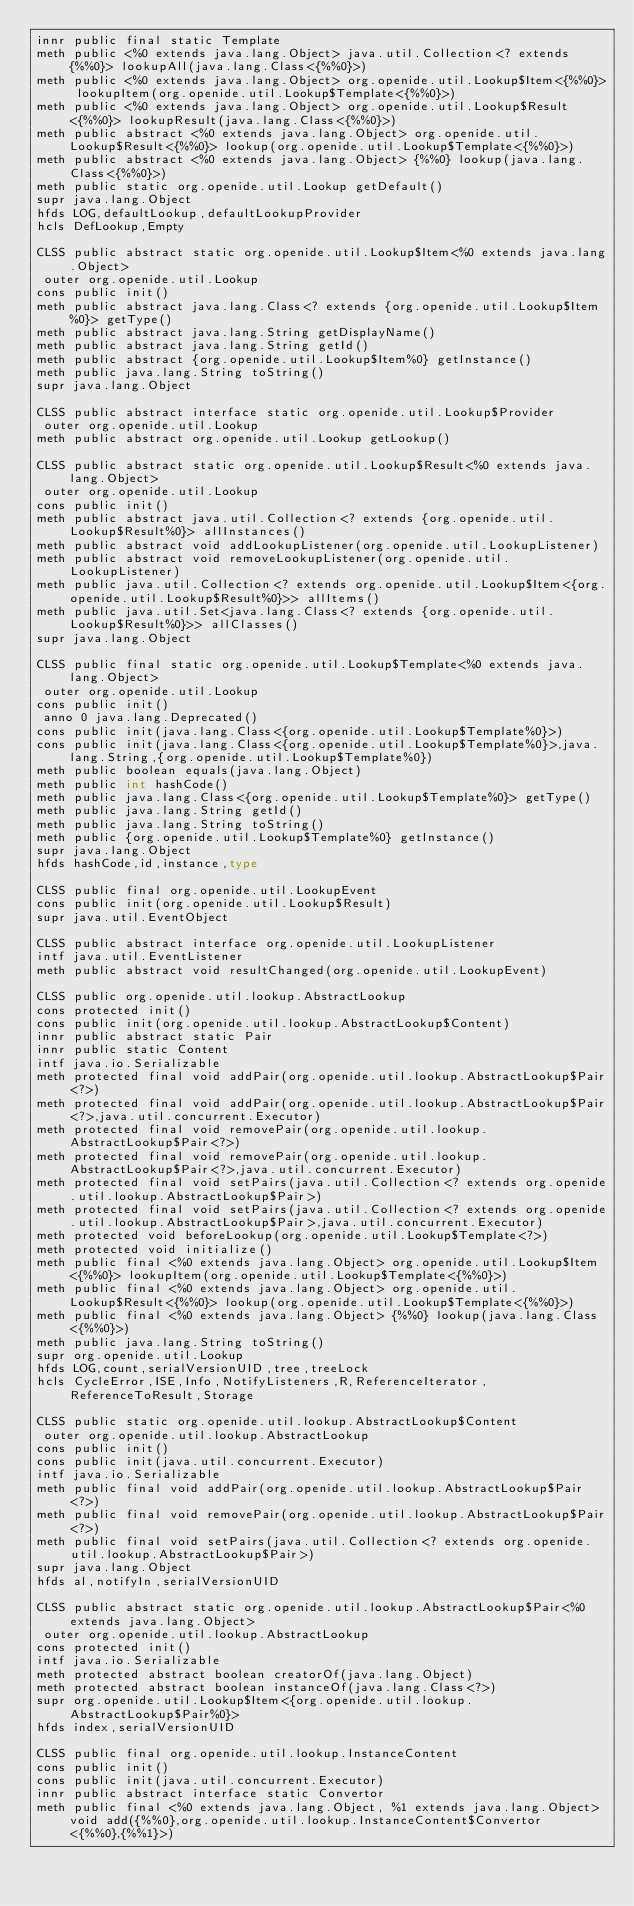<code> <loc_0><loc_0><loc_500><loc_500><_SML_>innr public final static Template
meth public <%0 extends java.lang.Object> java.util.Collection<? extends {%%0}> lookupAll(java.lang.Class<{%%0}>)
meth public <%0 extends java.lang.Object> org.openide.util.Lookup$Item<{%%0}> lookupItem(org.openide.util.Lookup$Template<{%%0}>)
meth public <%0 extends java.lang.Object> org.openide.util.Lookup$Result<{%%0}> lookupResult(java.lang.Class<{%%0}>)
meth public abstract <%0 extends java.lang.Object> org.openide.util.Lookup$Result<{%%0}> lookup(org.openide.util.Lookup$Template<{%%0}>)
meth public abstract <%0 extends java.lang.Object> {%%0} lookup(java.lang.Class<{%%0}>)
meth public static org.openide.util.Lookup getDefault()
supr java.lang.Object
hfds LOG,defaultLookup,defaultLookupProvider
hcls DefLookup,Empty

CLSS public abstract static org.openide.util.Lookup$Item<%0 extends java.lang.Object>
 outer org.openide.util.Lookup
cons public init()
meth public abstract java.lang.Class<? extends {org.openide.util.Lookup$Item%0}> getType()
meth public abstract java.lang.String getDisplayName()
meth public abstract java.lang.String getId()
meth public abstract {org.openide.util.Lookup$Item%0} getInstance()
meth public java.lang.String toString()
supr java.lang.Object

CLSS public abstract interface static org.openide.util.Lookup$Provider
 outer org.openide.util.Lookup
meth public abstract org.openide.util.Lookup getLookup()

CLSS public abstract static org.openide.util.Lookup$Result<%0 extends java.lang.Object>
 outer org.openide.util.Lookup
cons public init()
meth public abstract java.util.Collection<? extends {org.openide.util.Lookup$Result%0}> allInstances()
meth public abstract void addLookupListener(org.openide.util.LookupListener)
meth public abstract void removeLookupListener(org.openide.util.LookupListener)
meth public java.util.Collection<? extends org.openide.util.Lookup$Item<{org.openide.util.Lookup$Result%0}>> allItems()
meth public java.util.Set<java.lang.Class<? extends {org.openide.util.Lookup$Result%0}>> allClasses()
supr java.lang.Object

CLSS public final static org.openide.util.Lookup$Template<%0 extends java.lang.Object>
 outer org.openide.util.Lookup
cons public init()
 anno 0 java.lang.Deprecated()
cons public init(java.lang.Class<{org.openide.util.Lookup$Template%0}>)
cons public init(java.lang.Class<{org.openide.util.Lookup$Template%0}>,java.lang.String,{org.openide.util.Lookup$Template%0})
meth public boolean equals(java.lang.Object)
meth public int hashCode()
meth public java.lang.Class<{org.openide.util.Lookup$Template%0}> getType()
meth public java.lang.String getId()
meth public java.lang.String toString()
meth public {org.openide.util.Lookup$Template%0} getInstance()
supr java.lang.Object
hfds hashCode,id,instance,type

CLSS public final org.openide.util.LookupEvent
cons public init(org.openide.util.Lookup$Result)
supr java.util.EventObject

CLSS public abstract interface org.openide.util.LookupListener
intf java.util.EventListener
meth public abstract void resultChanged(org.openide.util.LookupEvent)

CLSS public org.openide.util.lookup.AbstractLookup
cons protected init()
cons public init(org.openide.util.lookup.AbstractLookup$Content)
innr public abstract static Pair
innr public static Content
intf java.io.Serializable
meth protected final void addPair(org.openide.util.lookup.AbstractLookup$Pair<?>)
meth protected final void addPair(org.openide.util.lookup.AbstractLookup$Pair<?>,java.util.concurrent.Executor)
meth protected final void removePair(org.openide.util.lookup.AbstractLookup$Pair<?>)
meth protected final void removePair(org.openide.util.lookup.AbstractLookup$Pair<?>,java.util.concurrent.Executor)
meth protected final void setPairs(java.util.Collection<? extends org.openide.util.lookup.AbstractLookup$Pair>)
meth protected final void setPairs(java.util.Collection<? extends org.openide.util.lookup.AbstractLookup$Pair>,java.util.concurrent.Executor)
meth protected void beforeLookup(org.openide.util.Lookup$Template<?>)
meth protected void initialize()
meth public final <%0 extends java.lang.Object> org.openide.util.Lookup$Item<{%%0}> lookupItem(org.openide.util.Lookup$Template<{%%0}>)
meth public final <%0 extends java.lang.Object> org.openide.util.Lookup$Result<{%%0}> lookup(org.openide.util.Lookup$Template<{%%0}>)
meth public final <%0 extends java.lang.Object> {%%0} lookup(java.lang.Class<{%%0}>)
meth public java.lang.String toString()
supr org.openide.util.Lookup
hfds LOG,count,serialVersionUID,tree,treeLock
hcls CycleError,ISE,Info,NotifyListeners,R,ReferenceIterator,ReferenceToResult,Storage

CLSS public static org.openide.util.lookup.AbstractLookup$Content
 outer org.openide.util.lookup.AbstractLookup
cons public init()
cons public init(java.util.concurrent.Executor)
intf java.io.Serializable
meth public final void addPair(org.openide.util.lookup.AbstractLookup$Pair<?>)
meth public final void removePair(org.openide.util.lookup.AbstractLookup$Pair<?>)
meth public final void setPairs(java.util.Collection<? extends org.openide.util.lookup.AbstractLookup$Pair>)
supr java.lang.Object
hfds al,notifyIn,serialVersionUID

CLSS public abstract static org.openide.util.lookup.AbstractLookup$Pair<%0 extends java.lang.Object>
 outer org.openide.util.lookup.AbstractLookup
cons protected init()
intf java.io.Serializable
meth protected abstract boolean creatorOf(java.lang.Object)
meth protected abstract boolean instanceOf(java.lang.Class<?>)
supr org.openide.util.Lookup$Item<{org.openide.util.lookup.AbstractLookup$Pair%0}>
hfds index,serialVersionUID

CLSS public final org.openide.util.lookup.InstanceContent
cons public init()
cons public init(java.util.concurrent.Executor)
innr public abstract interface static Convertor
meth public final <%0 extends java.lang.Object, %1 extends java.lang.Object> void add({%%0},org.openide.util.lookup.InstanceContent$Convertor<{%%0},{%%1}>)</code> 